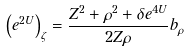Convert formula to latex. <formula><loc_0><loc_0><loc_500><loc_500>\left ( e ^ { 2 U } \right ) _ { \zeta } = \frac { Z ^ { 2 } + \rho ^ { 2 } + \delta e ^ { 4 U } } { 2 Z \rho } b _ { \rho }</formula> 